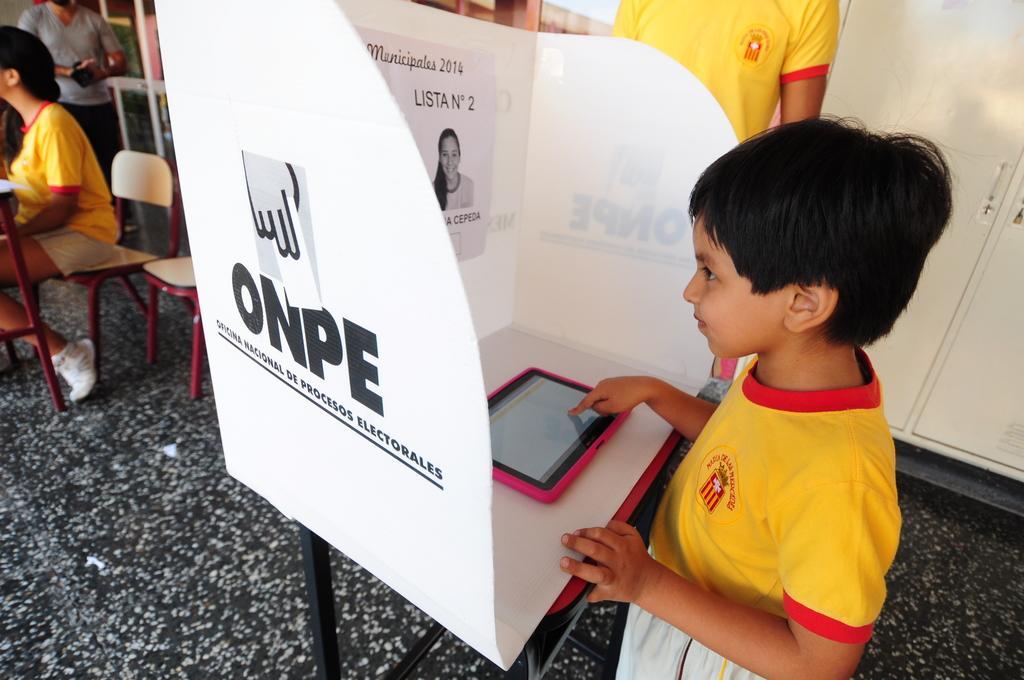Please provide a concise description of this image. There is a kid with yellow t-shirt playing on tablet and there is a door behind him. On left side corner there is a girl sat on chair,she wore white shoe. it seems to be a room in school,At the corner a man stood. 